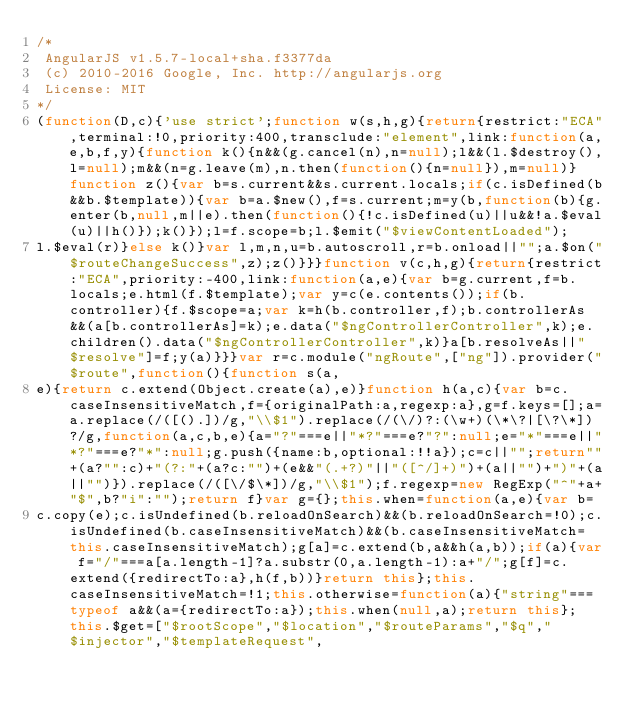<code> <loc_0><loc_0><loc_500><loc_500><_JavaScript_>/*
 AngularJS v1.5.7-local+sha.f3377da
 (c) 2010-2016 Google, Inc. http://angularjs.org
 License: MIT
*/
(function(D,c){'use strict';function w(s,h,g){return{restrict:"ECA",terminal:!0,priority:400,transclude:"element",link:function(a,e,b,f,y){function k(){n&&(g.cancel(n),n=null);l&&(l.$destroy(),l=null);m&&(n=g.leave(m),n.then(function(){n=null}),m=null)}function z(){var b=s.current&&s.current.locals;if(c.isDefined(b&&b.$template)){var b=a.$new(),f=s.current;m=y(b,function(b){g.enter(b,null,m||e).then(function(){!c.isDefined(u)||u&&!a.$eval(u)||h()});k()});l=f.scope=b;l.$emit("$viewContentLoaded");
l.$eval(r)}else k()}var l,m,n,u=b.autoscroll,r=b.onload||"";a.$on("$routeChangeSuccess",z);z()}}}function v(c,h,g){return{restrict:"ECA",priority:-400,link:function(a,e){var b=g.current,f=b.locals;e.html(f.$template);var y=c(e.contents());if(b.controller){f.$scope=a;var k=h(b.controller,f);b.controllerAs&&(a[b.controllerAs]=k);e.data("$ngControllerController",k);e.children().data("$ngControllerController",k)}a[b.resolveAs||"$resolve"]=f;y(a)}}}var r=c.module("ngRoute",["ng"]).provider("$route",function(){function s(a,
e){return c.extend(Object.create(a),e)}function h(a,c){var b=c.caseInsensitiveMatch,f={originalPath:a,regexp:a},g=f.keys=[];a=a.replace(/([().])/g,"\\$1").replace(/(\/)?:(\w+)(\*\?|[\?\*])?/g,function(a,c,b,e){a="?"===e||"*?"===e?"?":null;e="*"===e||"*?"===e?"*":null;g.push({name:b,optional:!!a});c=c||"";return""+(a?"":c)+"(?:"+(a?c:"")+(e&&"(.+?)"||"([^/]+)")+(a||"")+")"+(a||"")}).replace(/([\/$\*])/g,"\\$1");f.regexp=new RegExp("^"+a+"$",b?"i":"");return f}var g={};this.when=function(a,e){var b=
c.copy(e);c.isUndefined(b.reloadOnSearch)&&(b.reloadOnSearch=!0);c.isUndefined(b.caseInsensitiveMatch)&&(b.caseInsensitiveMatch=this.caseInsensitiveMatch);g[a]=c.extend(b,a&&h(a,b));if(a){var f="/"===a[a.length-1]?a.substr(0,a.length-1):a+"/";g[f]=c.extend({redirectTo:a},h(f,b))}return this};this.caseInsensitiveMatch=!1;this.otherwise=function(a){"string"===typeof a&&(a={redirectTo:a});this.when(null,a);return this};this.$get=["$rootScope","$location","$routeParams","$q","$injector","$templateRequest",</code> 